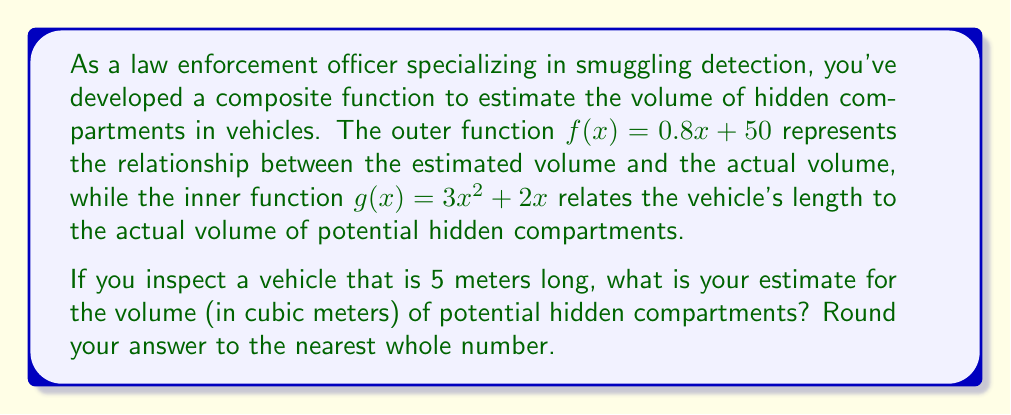Help me with this question. To solve this problem, we need to use the concept of composite functions. We'll evaluate the inner function first, then use its result as the input for the outer function.

1. The inner function $g(x)$ relates the vehicle's length to the actual volume:
   $g(x) = 3x^2 + 2x$

2. Given the vehicle length of 5 meters, we evaluate $g(5)$:
   $g(5) = 3(5)^2 + 2(5) = 3(25) + 10 = 75 + 10 = 85$

3. The result of $g(5)$ becomes the input for the outer function $f(x)$:
   $f(x) = 0.8x + 50$

4. We now evaluate $f(85)$:
   $f(85) = 0.8(85) + 50 = 68 + 50 = 118$

5. Rounding to the nearest whole number:
   118 rounds to 118 (no change)

Therefore, for a vehicle 5 meters long, we estimate the volume of potential hidden compartments to be 118 cubic meters.
Answer: 118 cubic meters 